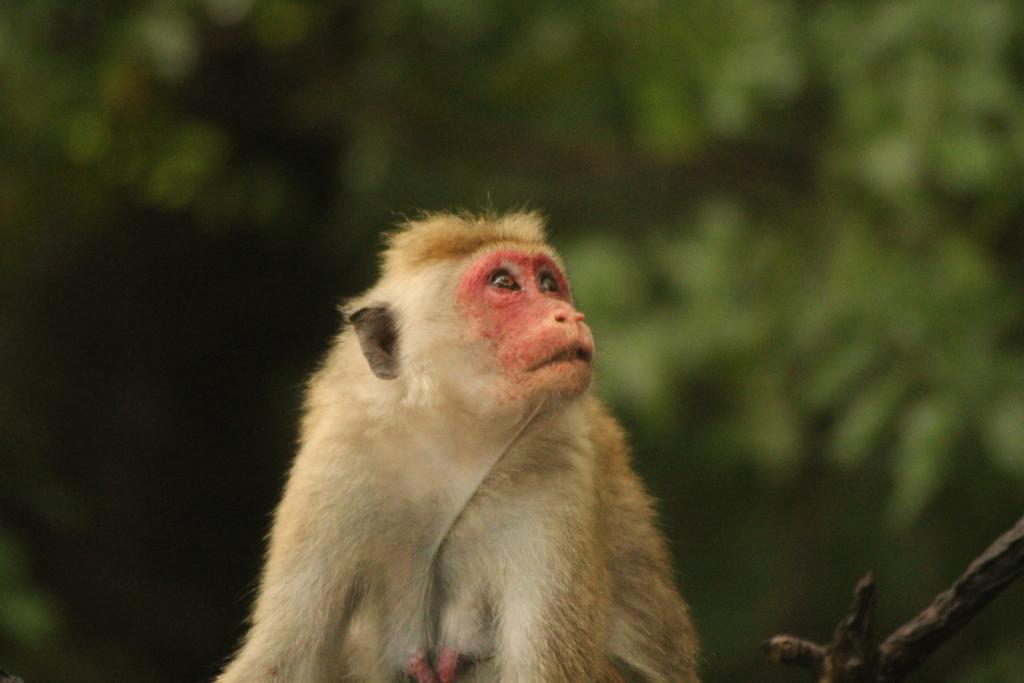In one or two sentences, can you explain what this image depicts? In this image I can see the monkey in brown and white color. Background is in green and black color. 